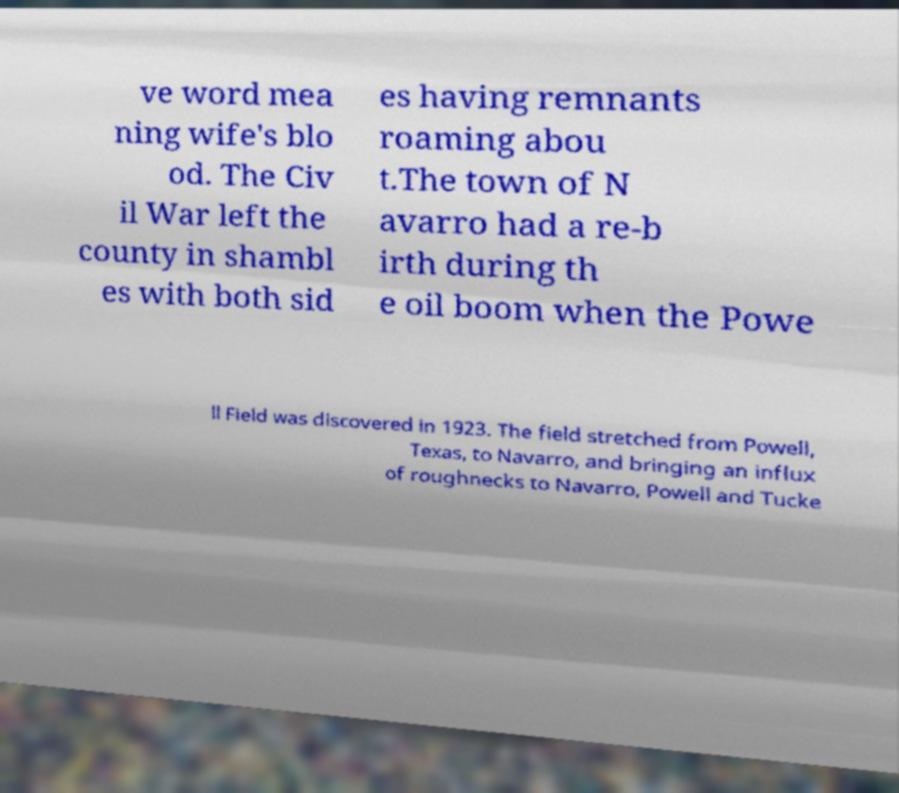There's text embedded in this image that I need extracted. Can you transcribe it verbatim? ve word mea ning wife's blo od. The Civ il War left the county in shambl es with both sid es having remnants roaming abou t.The town of N avarro had a re-b irth during th e oil boom when the Powe ll Field was discovered in 1923. The field stretched from Powell, Texas, to Navarro, and bringing an influx of roughnecks to Navarro, Powell and Tucke 